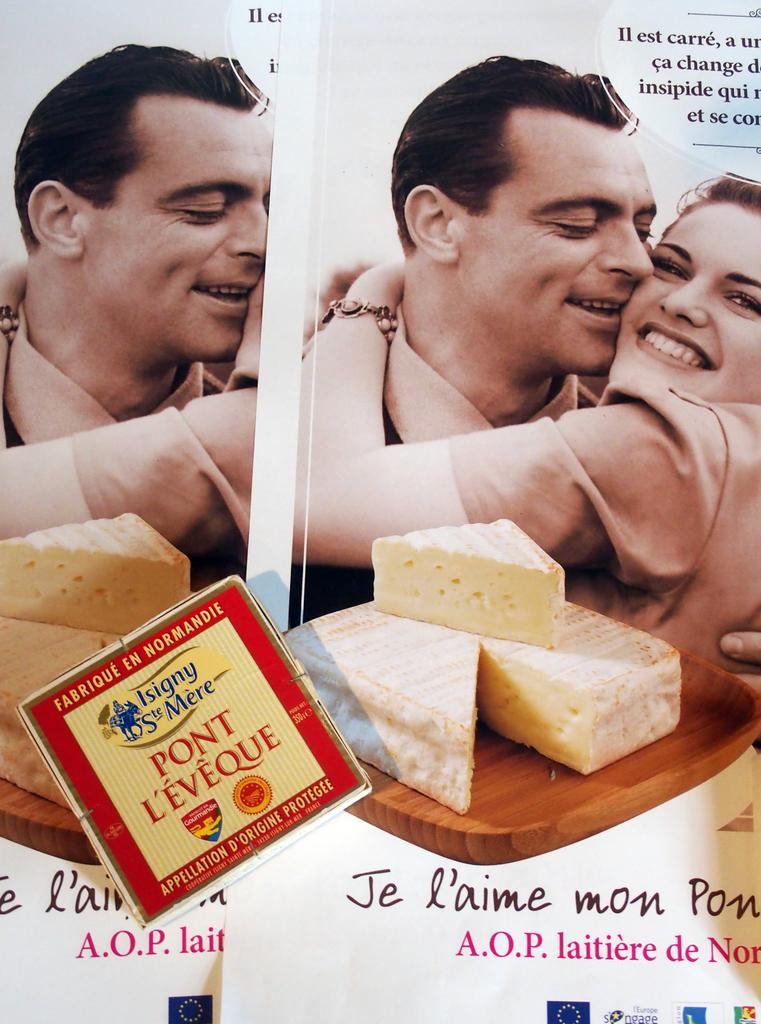What can be seen on the walls in the image? There are posters in the image. What is the man doing in the image? The man is holding a woman in the image. What food item is present on a table in the image? There is cheese on a table in the image. Where is a piece of text located in the image? There is a quotation in the top right corner of the image. What type of scissors can be seen in the image? There are no scissors present in the image. Is the fan visible in the image? There is no fan present in the image. 